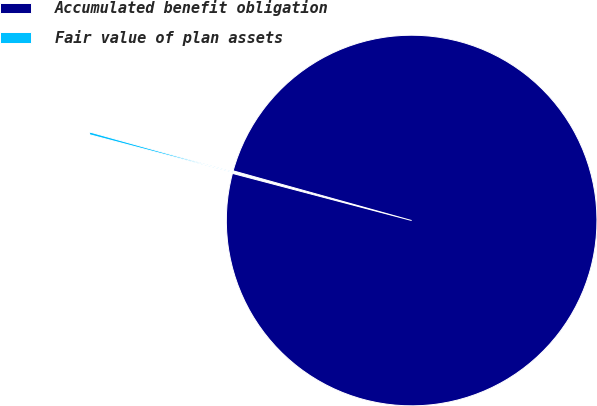Convert chart. <chart><loc_0><loc_0><loc_500><loc_500><pie_chart><fcel>Accumulated benefit obligation<fcel>Fair value of plan assets<nl><fcel>99.77%<fcel>0.23%<nl></chart> 